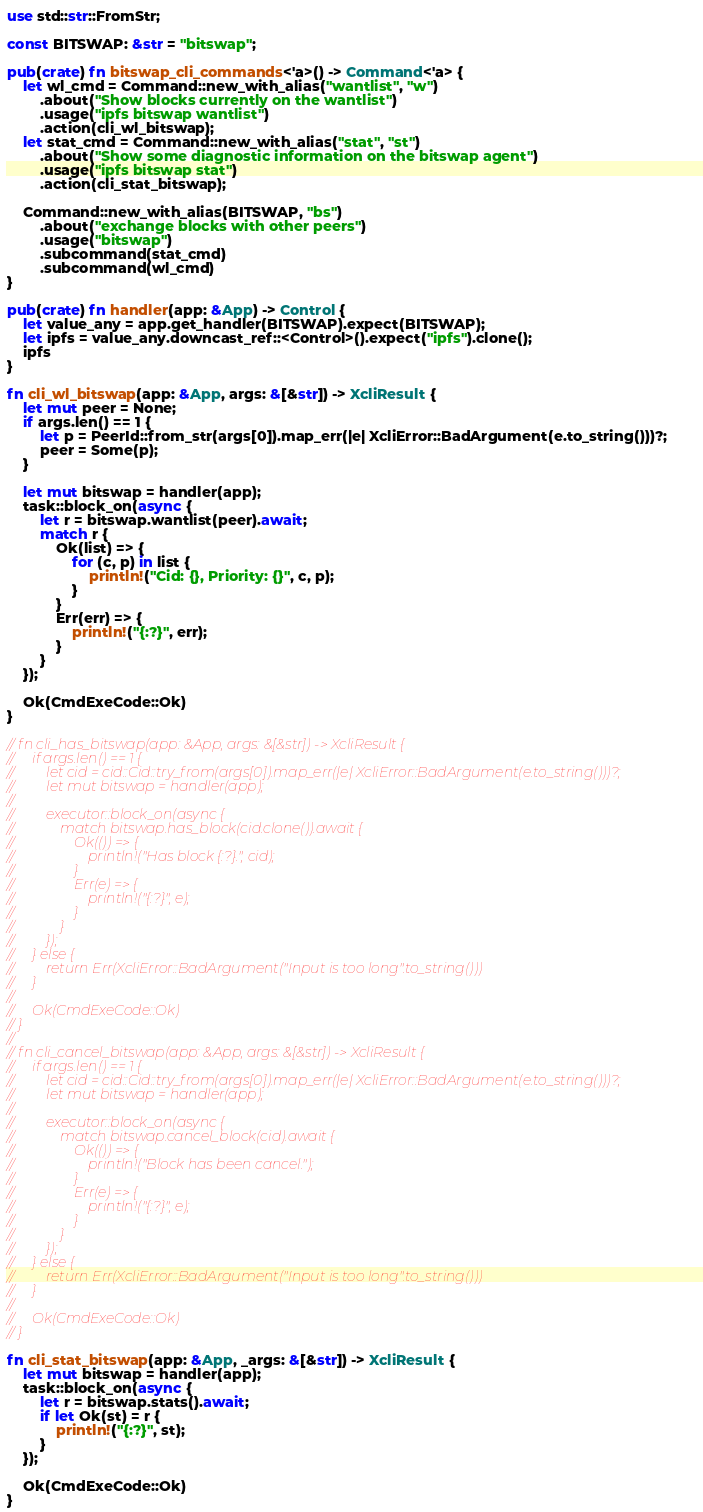<code> <loc_0><loc_0><loc_500><loc_500><_Rust_>use std::str::FromStr;

const BITSWAP: &str = "bitswap";

pub(crate) fn bitswap_cli_commands<'a>() -> Command<'a> {
    let wl_cmd = Command::new_with_alias("wantlist", "w")
        .about("Show blocks currently on the wantlist")
        .usage("ipfs bitswap wantlist")
        .action(cli_wl_bitswap);
    let stat_cmd = Command::new_with_alias("stat", "st")
        .about("Show some diagnostic information on the bitswap agent")
        .usage("ipfs bitswap stat")
        .action(cli_stat_bitswap);

    Command::new_with_alias(BITSWAP, "bs")
        .about("exchange blocks with other peers")
        .usage("bitswap")
        .subcommand(stat_cmd)
        .subcommand(wl_cmd)
}

pub(crate) fn handler(app: &App) -> Control {
    let value_any = app.get_handler(BITSWAP).expect(BITSWAP);
    let ipfs = value_any.downcast_ref::<Control>().expect("ipfs").clone();
    ipfs
}

fn cli_wl_bitswap(app: &App, args: &[&str]) -> XcliResult {
    let mut peer = None;
    if args.len() == 1 {
        let p = PeerId::from_str(args[0]).map_err(|e| XcliError::BadArgument(e.to_string()))?;
        peer = Some(p);
    }

    let mut bitswap = handler(app);
    task::block_on(async {
        let r = bitswap.wantlist(peer).await;
        match r {
            Ok(list) => {
                for (c, p) in list {
                    println!("Cid: {}, Priority: {}", c, p);
                }
            }
            Err(err) => {
                println!("{:?}", err);
            }
        }
    });

    Ok(CmdExeCode::Ok)
}

// fn cli_has_bitswap(app: &App, args: &[&str]) -> XcliResult {
//     if args.len() == 1 {
//         let cid = cid::Cid::try_from(args[0]).map_err(|e| XcliError::BadArgument(e.to_string()))?;
//         let mut bitswap = handler(app);
//
//         executor::block_on(async {
//             match bitswap.has_block(cid.clone()).await {
//                 Ok(()) => {
//                     println!("Has block {:?}.", cid);
//                 }
//                 Err(e) => {
//                     println!("{:?}", e);
//                 }
//             }
//         });
//     } else {
//         return Err(XcliError::BadArgument("Input is too long".to_string()))
//     }
//
//     Ok(CmdExeCode::Ok)
// }
//
// fn cli_cancel_bitswap(app: &App, args: &[&str]) -> XcliResult {
//     if args.len() == 1 {
//         let cid = cid::Cid::try_from(args[0]).map_err(|e| XcliError::BadArgument(e.to_string()))?;
//         let mut bitswap = handler(app);
//
//         executor::block_on(async {
//             match bitswap.cancel_block(cid).await {
//                 Ok(()) => {
//                     println!("Block has been cancel.");
//                 }
//                 Err(e) => {
//                     println!("{:?}", e);
//                 }
//             }
//         });
//     } else {
//         return Err(XcliError::BadArgument("Input is too long".to_string()))
//     }
//
//     Ok(CmdExeCode::Ok)
// }

fn cli_stat_bitswap(app: &App, _args: &[&str]) -> XcliResult {
    let mut bitswap = handler(app);
    task::block_on(async {
        let r = bitswap.stats().await;
        if let Ok(st) = r {
            println!("{:?}", st);
        }
    });

    Ok(CmdExeCode::Ok)
}
</code> 